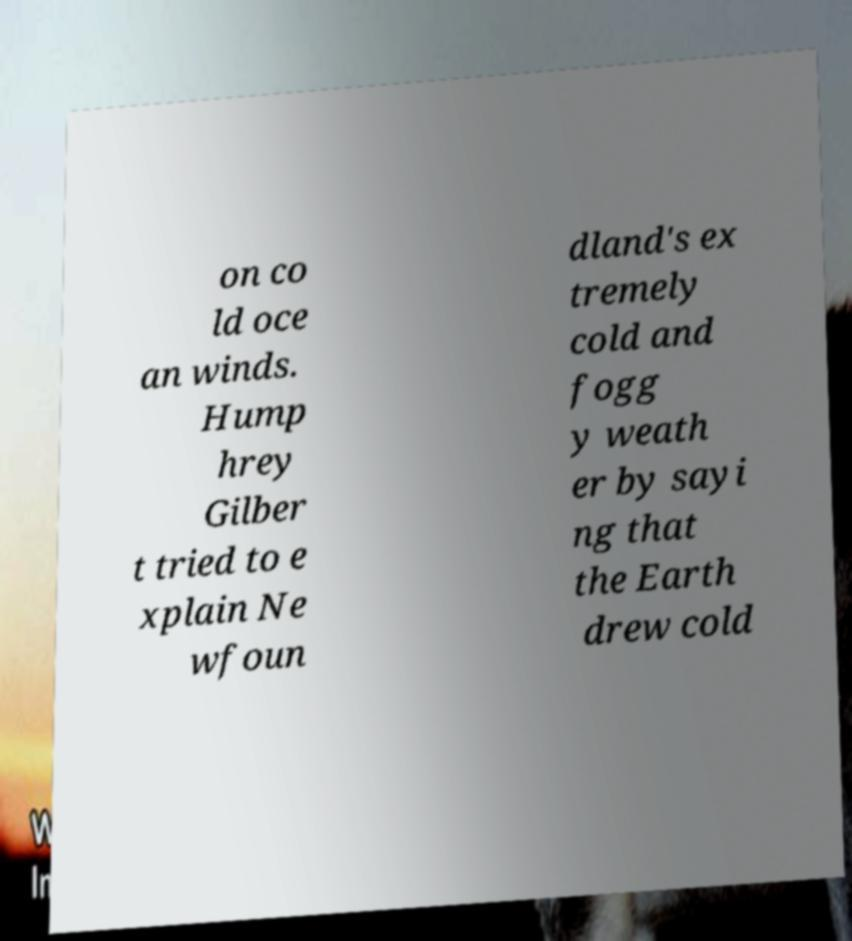Could you extract and type out the text from this image? on co ld oce an winds. Hump hrey Gilber t tried to e xplain Ne wfoun dland's ex tremely cold and fogg y weath er by sayi ng that the Earth drew cold 